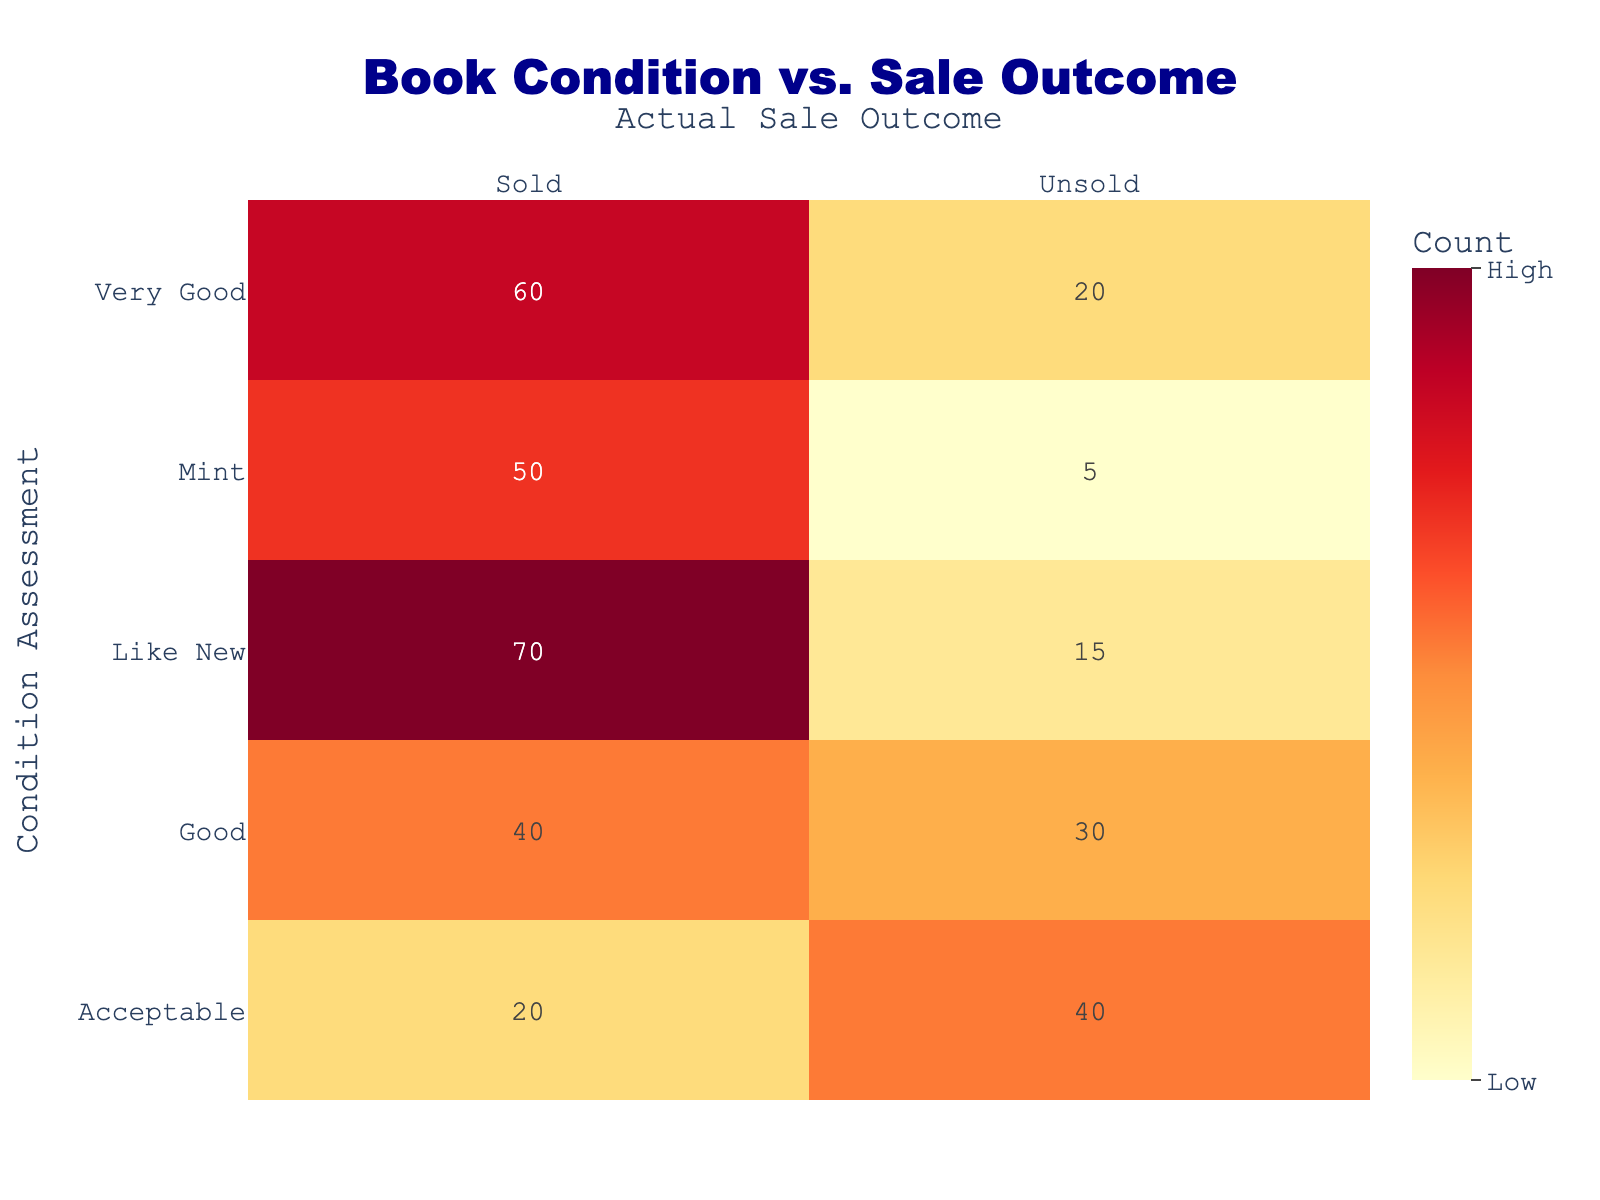What is the total number of books assessed as "Mint" that were sold? There are 50 books assessed as "Mint" and marked as sold. This value is directly retrieved from the table.
Answer: 50 How many books in "Acceptable" condition were unsold? The table indicates that there are 40 books in "Acceptable" condition that were marked as unsold. This value can simply be looked up in the table.
Answer: 40 Which condition assessment had the highest number of sold books? By looking at the rows for sold books, "Like New" has the highest count with 70 books sold, compared to "Mint" with 50, "Very Good" with 60, "Good" with 40, and "Acceptable" with 20.
Answer: Like New What is the sum of all unsold books across all condition assessments? To find the total number of unsold books, we look at each unsold count: Mint (5), Like New (15), Very Good (20), Good (30), and Acceptable (40). Adding these gives 5 + 15 + 20 + 30 + 40 = 110.
Answer: 110 Is it true that there were more "Very Good" books sold than "Good" books? Yes, "Very Good" had 60 sold books, while "Good" had 40 sold books, thus meaning "Very Good" sold more. The comparison reveals the truth of the statement.
Answer: Yes What is the proportion of sold books in "Good" condition compared to total "Good" assessed books? In "Good" condition, 40 sold and 30 unsold means a total of 70 books. The proportion of sold books is therefore 40 sold out of 70 total, which simplifies to 40/70 = 4/7 or approximately 0.57.
Answer: 0.57 How many more books in "Like New" condition were sold compared to those in "Acceptable" condition? "Like New" sold 70 books, and "Acceptable" sold 20 books. The difference is 70 - 20 = 50, indicating that "Like New" had 50 more books sold than "Acceptable".
Answer: 50 What is the average number of sold books across all condition assessments? The sold counts are 50 (Mint), 70 (Like New), 60 (Very Good), 40 (Good), and 20 (Acceptable). The total sold books = 50 + 70 + 60 + 40 + 20 = 240. Since there are 5 condition assessments, the average is 240 / 5 = 48.
Answer: 48 